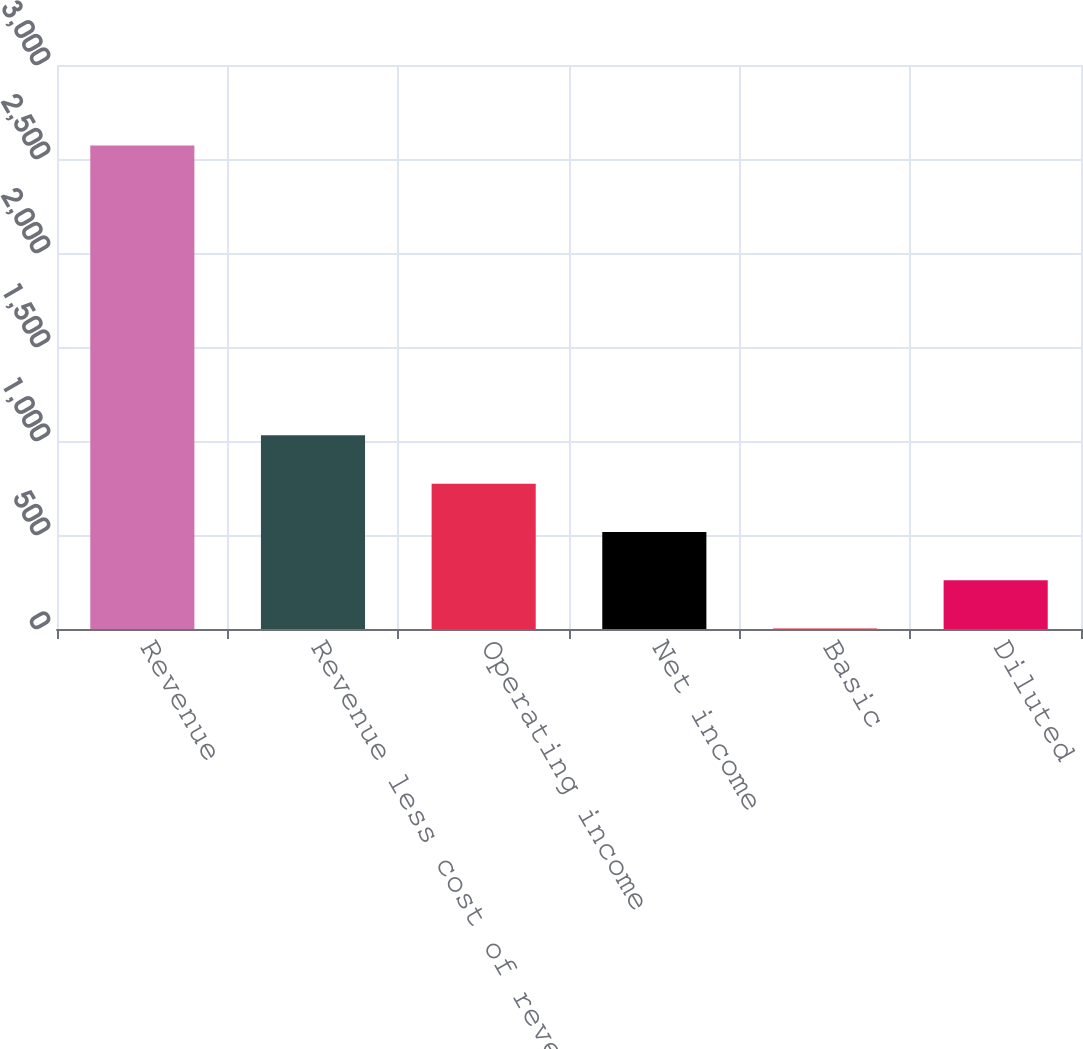Convert chart. <chart><loc_0><loc_0><loc_500><loc_500><bar_chart><fcel>Revenue<fcel>Revenue less cost of revenues<fcel>Operating income<fcel>Net income<fcel>Basic<fcel>Diluted<nl><fcel>2572<fcel>1030.02<fcel>773.03<fcel>516.04<fcel>2.06<fcel>259.05<nl></chart> 